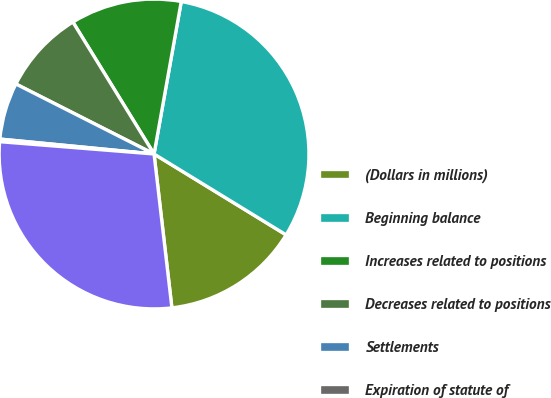Convert chart. <chart><loc_0><loc_0><loc_500><loc_500><pie_chart><fcel>(Dollars in millions)<fcel>Beginning balance<fcel>Increases related to positions<fcel>Decreases related to positions<fcel>Settlements<fcel>Expiration of statute of<fcel>Ending balance<nl><fcel>14.42%<fcel>30.94%<fcel>11.59%<fcel>8.76%<fcel>5.93%<fcel>0.27%<fcel>28.11%<nl></chart> 